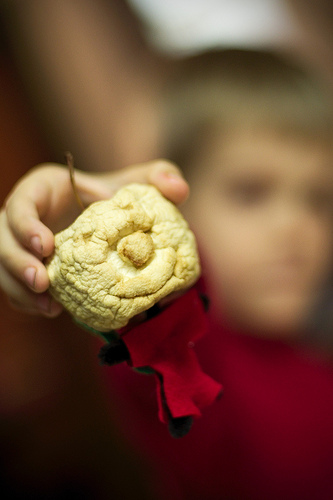<image>
Is there a white lump behind the boy? No. The white lump is not behind the boy. From this viewpoint, the white lump appears to be positioned elsewhere in the scene. 